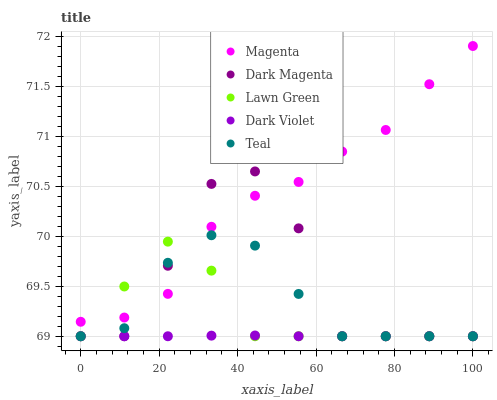Does Dark Violet have the minimum area under the curve?
Answer yes or no. Yes. Does Magenta have the maximum area under the curve?
Answer yes or no. Yes. Does Lawn Green have the minimum area under the curve?
Answer yes or no. No. Does Lawn Green have the maximum area under the curve?
Answer yes or no. No. Is Dark Violet the smoothest?
Answer yes or no. Yes. Is Dark Magenta the roughest?
Answer yes or no. Yes. Is Lawn Green the smoothest?
Answer yes or no. No. Is Lawn Green the roughest?
Answer yes or no. No. Does Teal have the lowest value?
Answer yes or no. Yes. Does Magenta have the lowest value?
Answer yes or no. No. Does Magenta have the highest value?
Answer yes or no. Yes. Does Lawn Green have the highest value?
Answer yes or no. No. Is Dark Violet less than Magenta?
Answer yes or no. Yes. Is Magenta greater than Dark Violet?
Answer yes or no. Yes. Does Lawn Green intersect Teal?
Answer yes or no. Yes. Is Lawn Green less than Teal?
Answer yes or no. No. Is Lawn Green greater than Teal?
Answer yes or no. No. Does Dark Violet intersect Magenta?
Answer yes or no. No. 